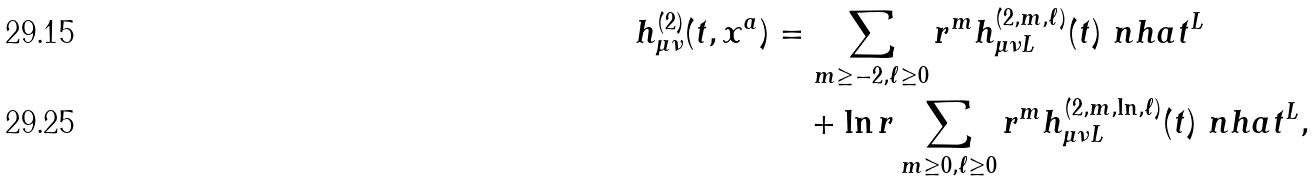<formula> <loc_0><loc_0><loc_500><loc_500>h ^ { ( 2 ) } _ { \mu \nu } ( t , x ^ { a } ) & = \sum _ { m \geq - 2 , \ell \geq 0 } r ^ { m } h ^ { ( 2 , m , \ell ) } _ { \mu \nu L } ( t ) \ n h a t ^ { L } \\ & \quad + \ln r \sum _ { m \geq 0 , \ell \geq 0 } r ^ { m } h ^ { ( 2 , m , \ln , \ell ) } _ { \mu \nu L } ( t ) \ n h a t ^ { L } ,</formula> 